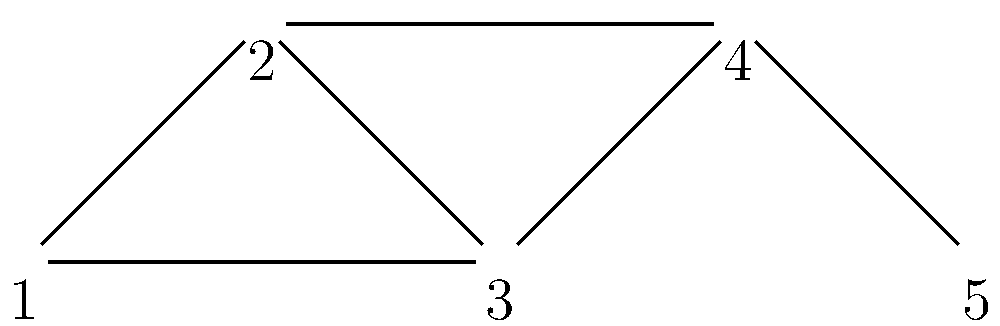In the network topology shown above, which node has the highest degree centrality? Explain your reasoning considering the importance of degree centrality in network analysis. To determine the node with the highest degree centrality, we need to follow these steps:

1. Understand degree centrality:
   - Degree centrality is a measure of the number of direct connections a node has in a network.
   - It indicates how well-connected or influential a node is within the network.

2. Count the connections for each node:
   - Node 1: Connected to nodes 2 and 3 (2 connections)
   - Node 2: Connected to nodes 1, 3, and 4 (3 connections)
   - Node 3: Connected to nodes 1, 2, 4, and 5 (4 connections)
   - Node 4: Connected to nodes 2, 3, and 5 (3 connections)
   - Node 5: Connected to nodes 3 and 4 (2 connections)

3. Identify the node with the highest number of connections:
   - Node 3 has the most connections (4), giving it the highest degree centrality.

4. Interpret the result:
   - In network analysis, nodes with high degree centrality are often considered more important or influential.
   - Node 3 is likely to have the most direct influence on the network and may act as a hub for information flow.

5. Relevance to news translation:
   - In the context of news translation, a node with high degree centrality could represent a key source or distributor of information, potentially making it a crucial point for ensuring accurate and timely translations.
Answer: Node 3 